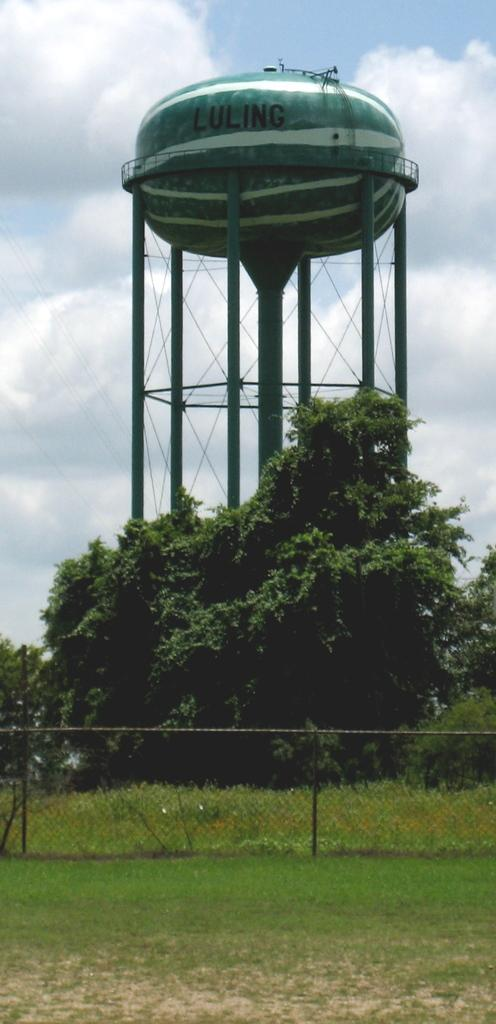What type of structure can be seen in the image? There is fencing in the image. What is on the surface where the fencing is located? Grass is present on the surface in the image. What can be seen in the background of the image? There are trees, a water tank, and the sky visible in the background of the image. Where is the hole in the image, and what is its purpose? There is no hole present in the image. The purpose of a hole cannot be determined in this context. 